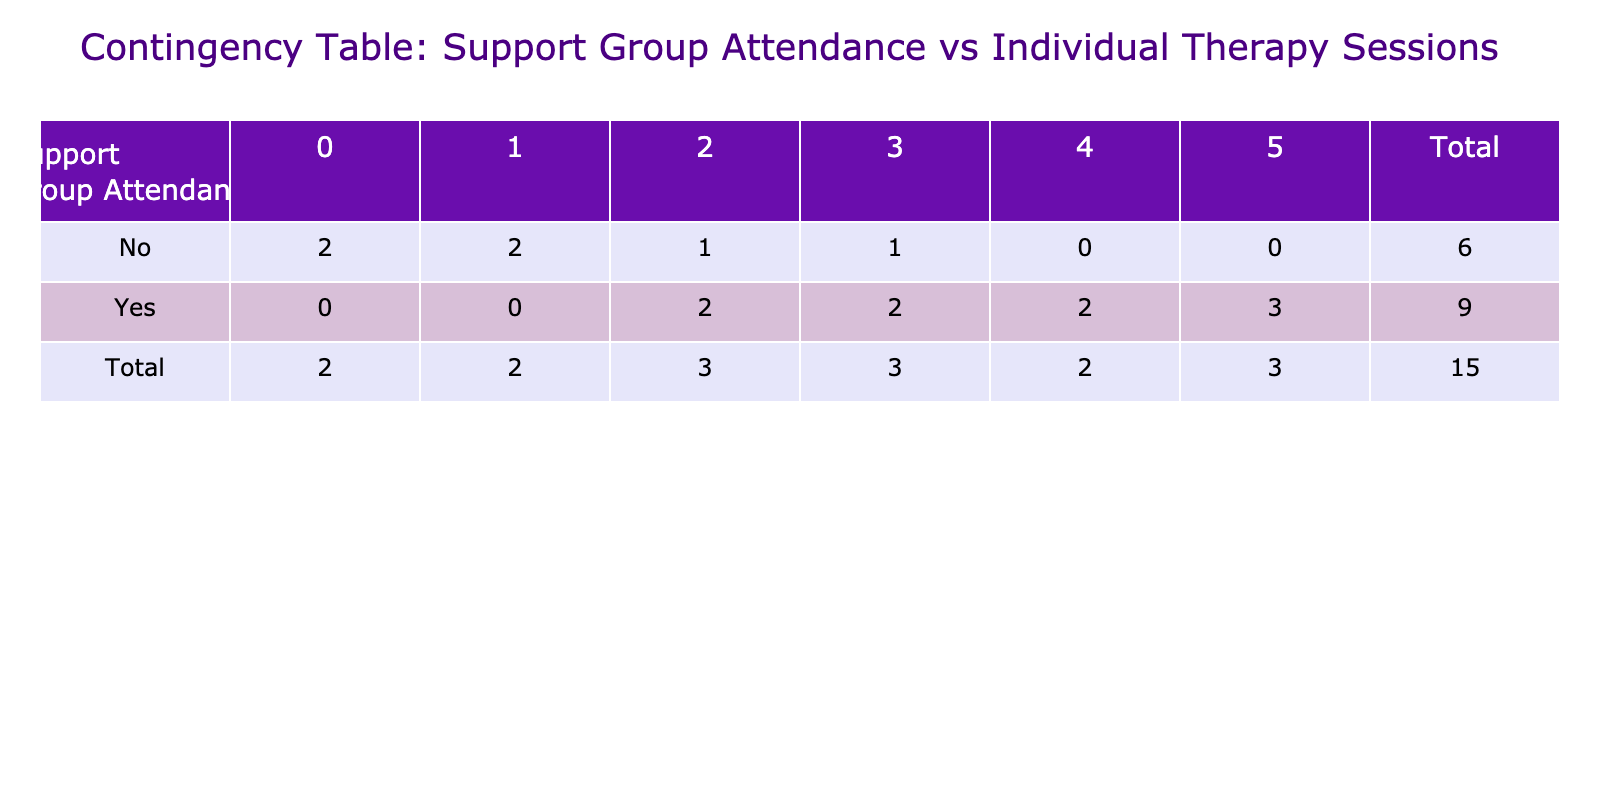What is the total number of clients who attended support groups? To find the total number of clients who attended support groups, look at the first column of the table under "Support Group Attendance." Count the "Yes" entries. There are 8 entries that indicate "Yes."
Answer: 8 What is the total number of individual therapy sessions attended by clients who did not attend support groups? First, identify the clients that did not attend support groups by looking for "No" in the "Support Group Attendance" column. These clients are 2, 5, 7, 10, and 14. Now, sum their individual therapy sessions: 3 + 1 + 0 + 2 + 0 = 6.
Answer: 6 Is it true that clients who attended support groups had an average of more than 3 individual therapy sessions? To verify this, first, find the individual therapy sessions for clients who attended support groups (4, 5, 5, 3, 2, 5, 3). Their total is 4 + 5 + 5 + 3 + 2 + 5 + 3 = 27 sessions. The average is then 27 sessions divided by 8 clients = 3.375. Since 3.375 is more than 3, the statement is true.
Answer: Yes How many clients attended exactly 3 individual therapy sessions? Look at the column for individual therapy sessions and count how many clients have the value "3." From the entries, clients 8 and 15 both attended exactly 3 sessions, which amounts to a total of 2 clients.
Answer: 2 What is the difference in total individual therapy sessions between clients who attended support groups and those who did not? First, calculate the total sessions for clients who attended support groups: (4 + 5 + 5 + 2 + 5 + 3 + 2 + 5) = 31. Then, calculate the total for those who did not: (3 + 1 + 0 + 2 + 0) = 6. Finally, subtract the total of clients who did not attend from those who did: 31 - 6 = 25.
Answer: 25 